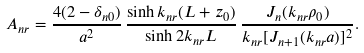Convert formula to latex. <formula><loc_0><loc_0><loc_500><loc_500>A _ { n r } = { \frac { 4 ( 2 - \delta _ { n 0 } ) } { a ^ { 2 } } } \, { \frac { \sinh k _ { n r } ( L + z _ { 0 } ) } { \sinh 2 k _ { n r } L } } \, { \frac { J _ { n } ( k _ { n r } \rho _ { 0 } ) } { k _ { n r } [ J _ { n + 1 } ( k _ { n r } a ) ] ^ { 2 } } } .</formula> 